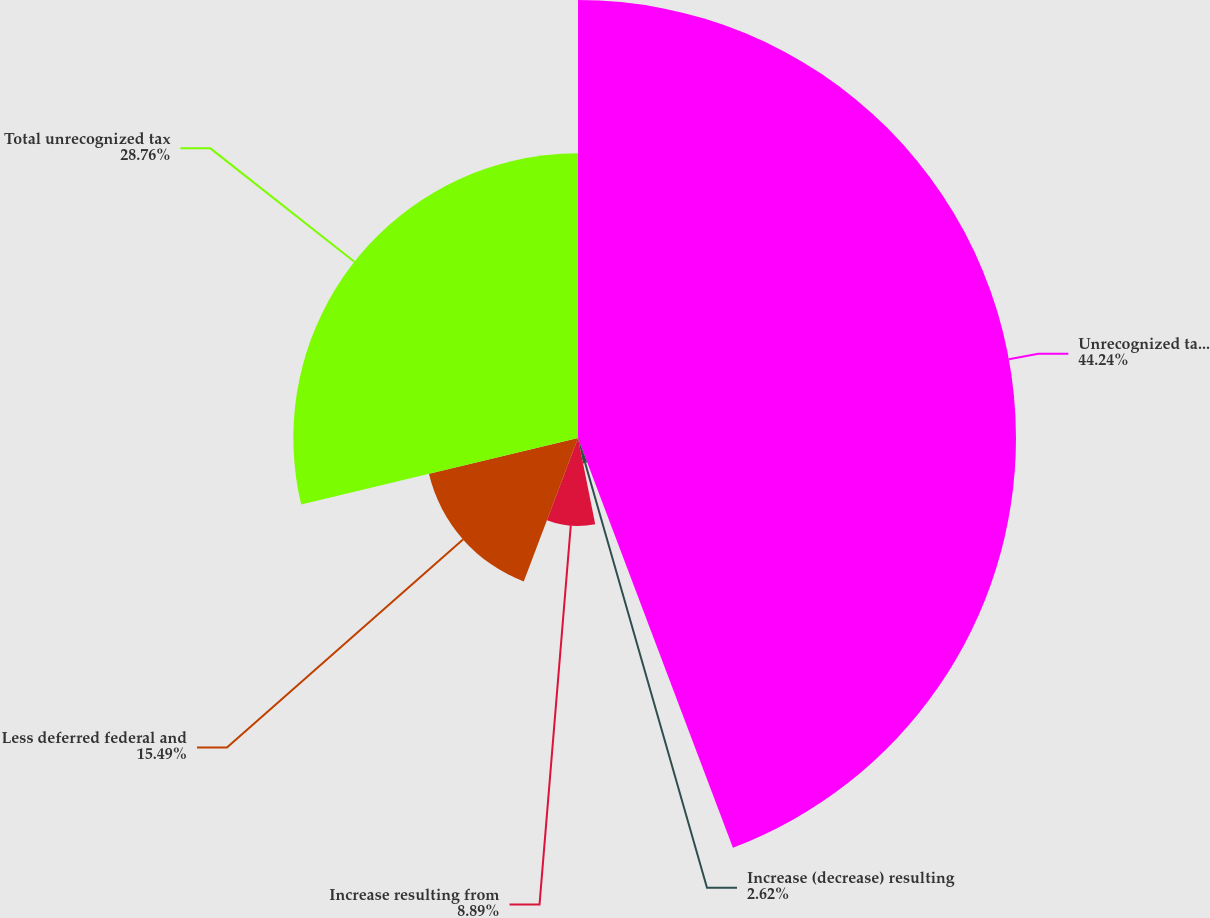Convert chart. <chart><loc_0><loc_0><loc_500><loc_500><pie_chart><fcel>Unrecognized tax benefits -<fcel>Increase (decrease) resulting<fcel>Increase resulting from<fcel>Less deferred federal and<fcel>Total unrecognized tax<nl><fcel>44.25%<fcel>2.62%<fcel>8.89%<fcel>15.49%<fcel>28.76%<nl></chart> 